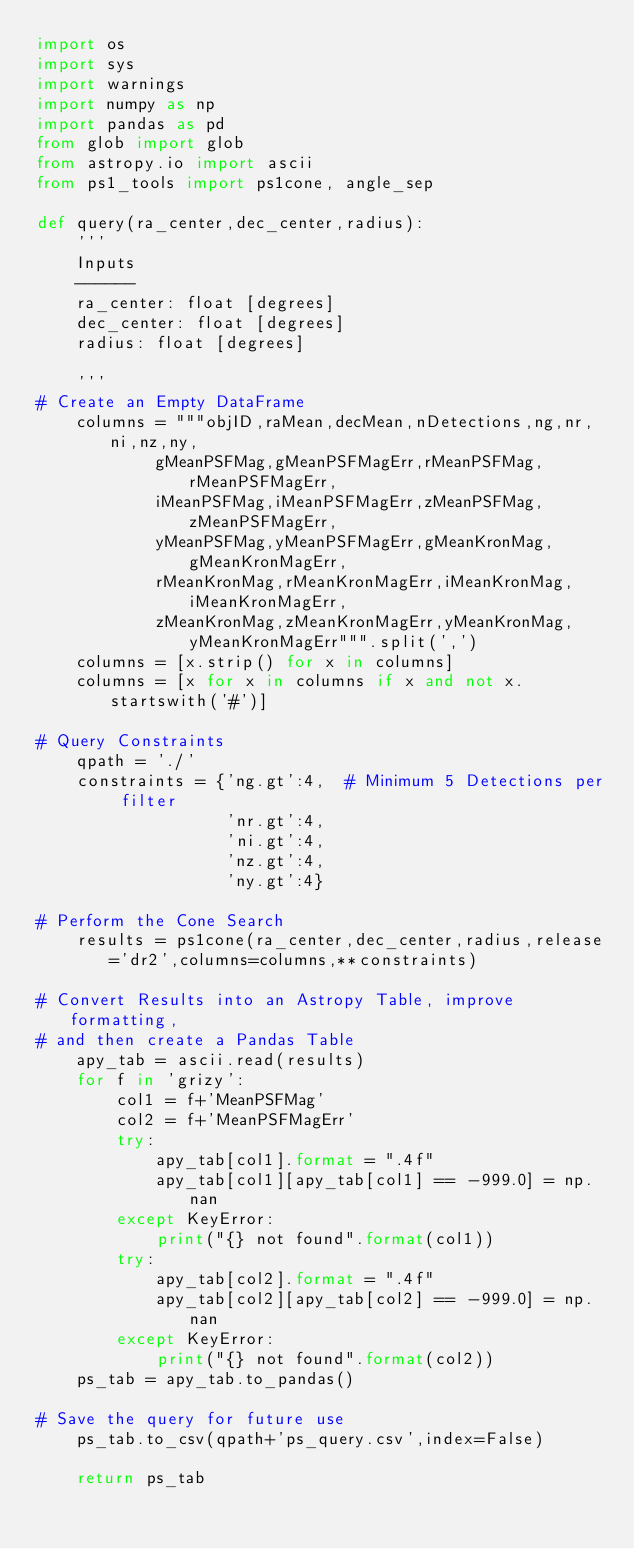<code> <loc_0><loc_0><loc_500><loc_500><_Python_>import os
import sys
import warnings
import numpy as np
import pandas as pd
from glob import glob
from astropy.io import ascii
from ps1_tools import ps1cone, angle_sep

def query(ra_center,dec_center,radius):
    '''
    Inputs
    ------
    ra_center: float [degrees]
    dec_center: float [degrees]
    radius: float [degrees]

    '''
# Create an Empty DataFrame
    columns = """objID,raMean,decMean,nDetections,ng,nr,ni,nz,ny,
            gMeanPSFMag,gMeanPSFMagErr,rMeanPSFMag,rMeanPSFMagErr,
            iMeanPSFMag,iMeanPSFMagErr,zMeanPSFMag,zMeanPSFMagErr,
            yMeanPSFMag,yMeanPSFMagErr,gMeanKronMag,gMeanKronMagErr,
            rMeanKronMag,rMeanKronMagErr,iMeanKronMag,iMeanKronMagErr,
            zMeanKronMag,zMeanKronMagErr,yMeanKronMag,yMeanKronMagErr""".split(',')
    columns = [x.strip() for x in columns]
    columns = [x for x in columns if x and not x.startswith('#')]

# Query Constraints
    qpath = './'
    constraints = {'ng.gt':4,  # Minimum 5 Detections per filter
                   'nr.gt':4,
                   'ni.gt':4,
                   'nz.gt':4,
                   'ny.gt':4}

# Perform the Cone Search
    results = ps1cone(ra_center,dec_center,radius,release='dr2',columns=columns,**constraints)

# Convert Results into an Astropy Table, improve formatting,
# and then create a Pandas Table
    apy_tab = ascii.read(results)
    for f in 'grizy':
        col1 = f+'MeanPSFMag'
        col2 = f+'MeanPSFMagErr'
        try:
            apy_tab[col1].format = ".4f"
            apy_tab[col1][apy_tab[col1] == -999.0] = np.nan
        except KeyError:
            print("{} not found".format(col1))
        try:
            apy_tab[col2].format = ".4f"
            apy_tab[col2][apy_tab[col2] == -999.0] = np.nan
        except KeyError:
            print("{} not found".format(col2))
    ps_tab = apy_tab.to_pandas()

# Save the query for future use
    ps_tab.to_csv(qpath+'ps_query.csv',index=False)
    
    return ps_tab
</code> 